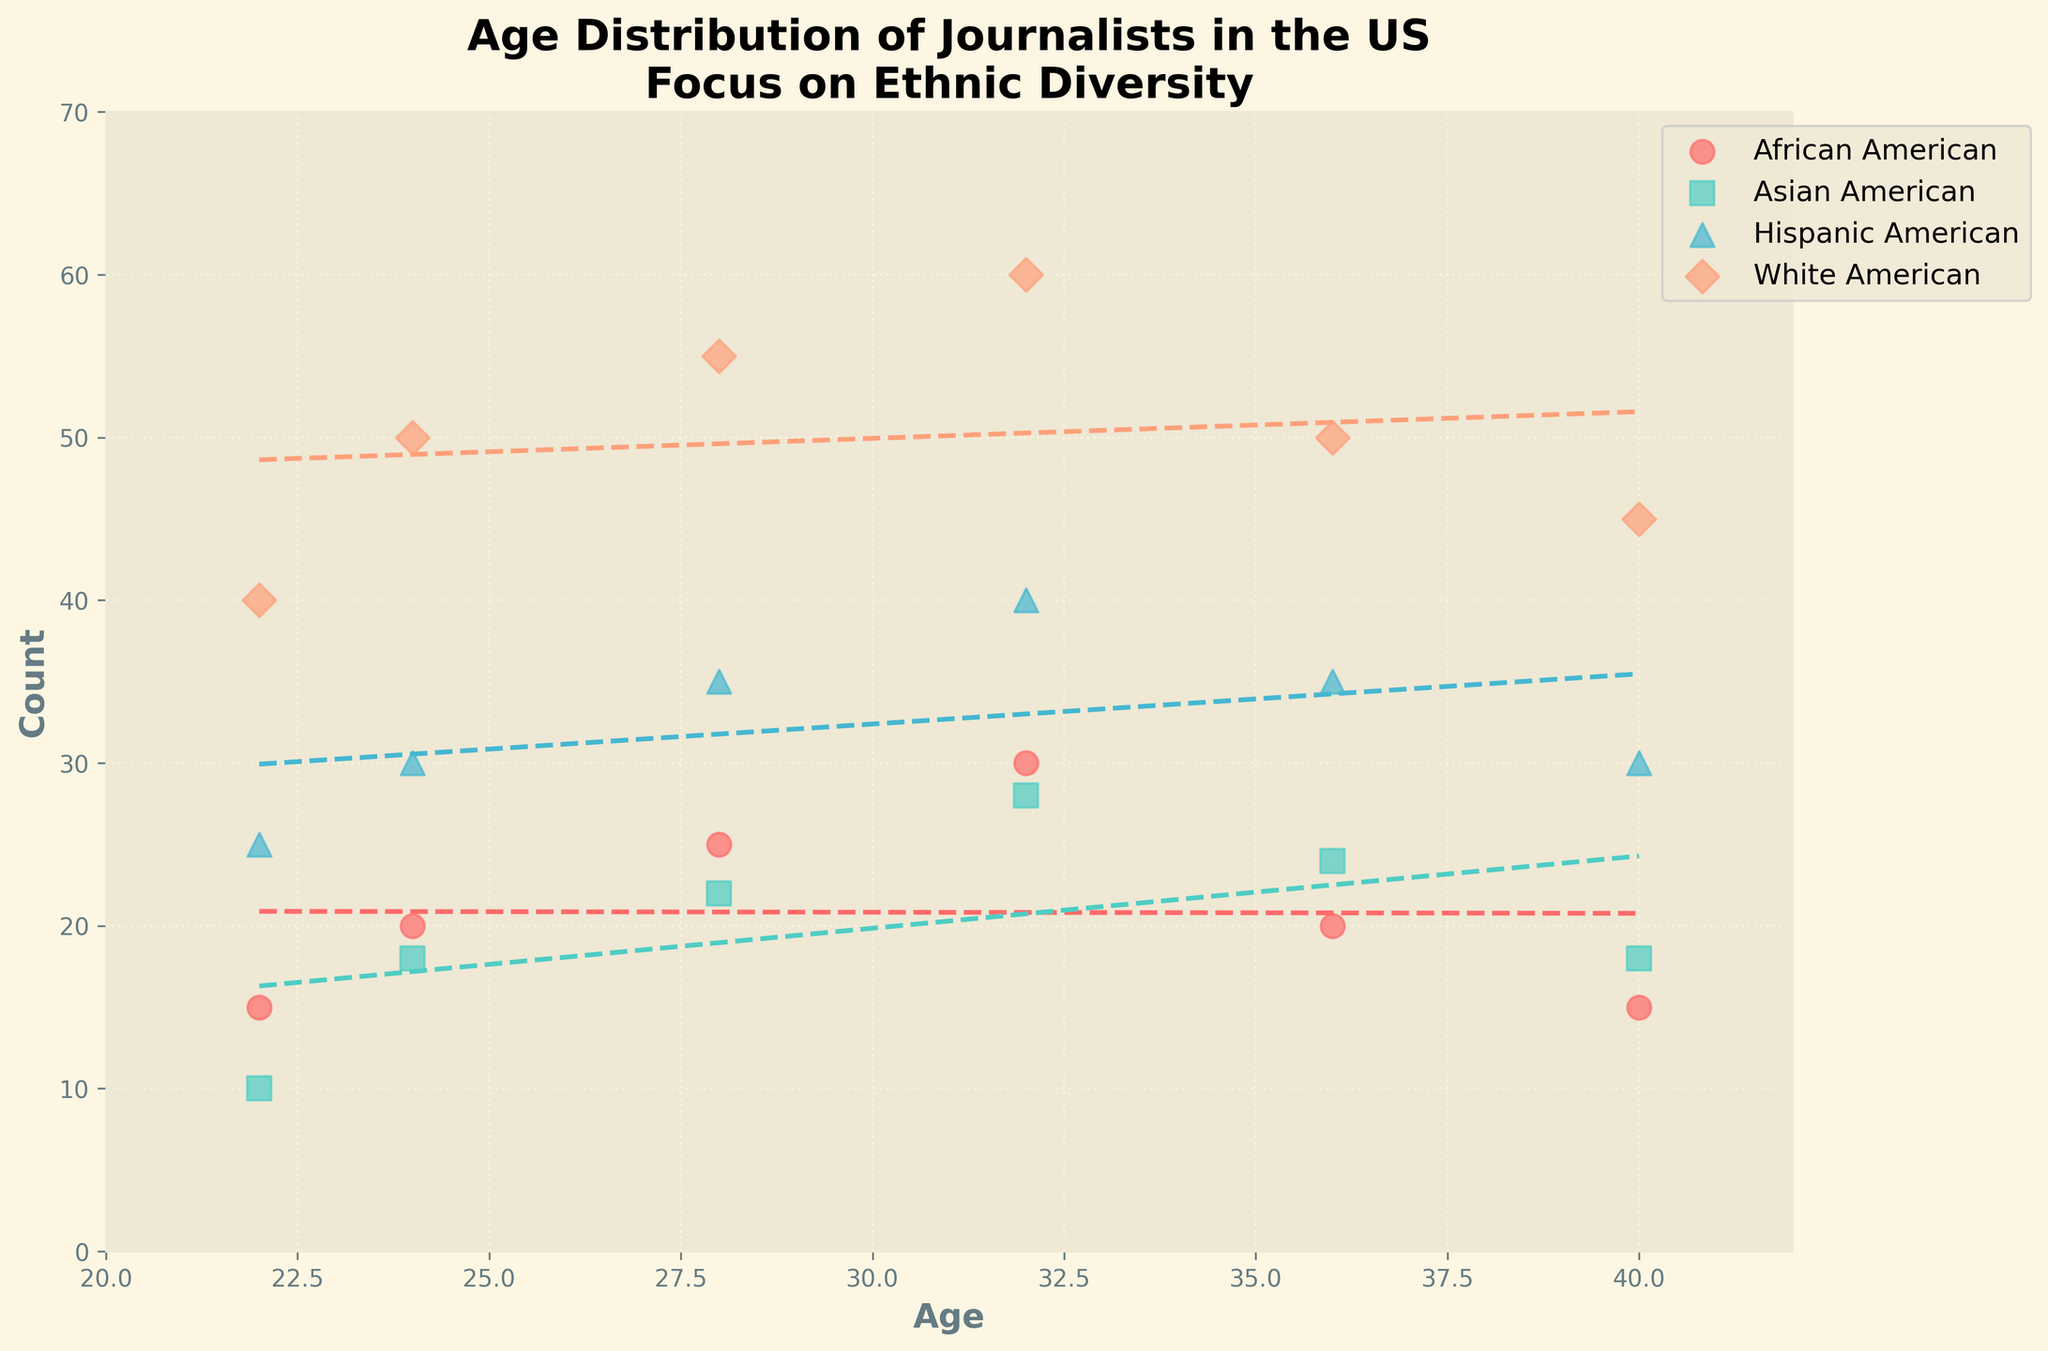What is the title of the plot? The title of the plot is usually found at the top and it summarizes what the plot is about. In this case, it is describing the age distribution of journalists in the US with a focus on ethnic diversity.
Answer: Age Distribution of Journalists in the US Focus on Ethnic Diversity Which ethnicity has the highest count at age 28? To determine this, look at the scatter points at age 28 and compare their counts among the different ethnicities. The ethnicity with the highest count value at age 28 has the most journalists.
Answer: White American What color represents African American journalists? Each ethnicity is represented by a unique color in the scatter plot. The color can be identified by looking at the legend, which matches the color to the ethnicity.
Answer: Red How does the trend line for Asian American journalists compare to that of Hispanic American journalists? The trend lines for each ethnicity indicate the overall trend in age distribution. By comparing the slopes of the trend lines for Asian American and Hispanic American journalists, we can understand whether the counts are increasing, decreasing, or remaining relatively constant as age increases.
Answer: The trend line for Hispanic American journalists has a steeper positive slope compared to that of Asian American journalists What is the approximate count of White American journalists at age 32? To find this, locate the scatter point for age 32 for White American journalists and check the corresponding count value.
Answer: 60 Between the ages of 22 and 40, during which age group do African American journalists show a decrease in count? Observe the trend line or the scatter points for African American journalists between ages 22 and 40. Identify any age interval where the count decreases.
Answer: Between ages 32 and 36 What pattern can be observed about the count of journalists as they age across different ethnicities? Compare the shapes and trends of the scatter points and trend lines for all ethnicities to identify any common patterns regarding how the count of journalists changes with age.
Answer: Generally, journalist counts increase until around age 32 and then decrease or stabilize Which ethnicity shows the least variation in counts across all ages? The variation in counts can be determined by observing how consistent the scatter points are for each ethnicity. The trend line's slope and scatter points' spread provide insights into this variation.
Answer: Asian American How does the count of Hispanic American journalists at age 40 compare to that of Asian American journalists at the same age? Compare the scatter points for Hispanic American and Asian American journalists at age 40 and see which has a higher count value.
Answer: Hispanic American journalists have a higher count than Asian American journalists at age 40 What can be inferred from the trend lines about the future count of journalists in these ethnic groups if current trends continue? Extrapolate from the slopes of the trend lines. If the trends continue, ethnicities with steeper positive slopes will see an increase in journalist counts, while those with less steep or negative slopes might see a decrease.
Answer: White and Hispanic American counts are likely to increase, while African American counts may decrease and Asian American counts will remain stable 